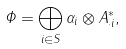Convert formula to latex. <formula><loc_0><loc_0><loc_500><loc_500>\Phi = \bigoplus _ { i \in S } \alpha _ { i } \otimes A _ { \cdot i } ^ { * } ,</formula> 